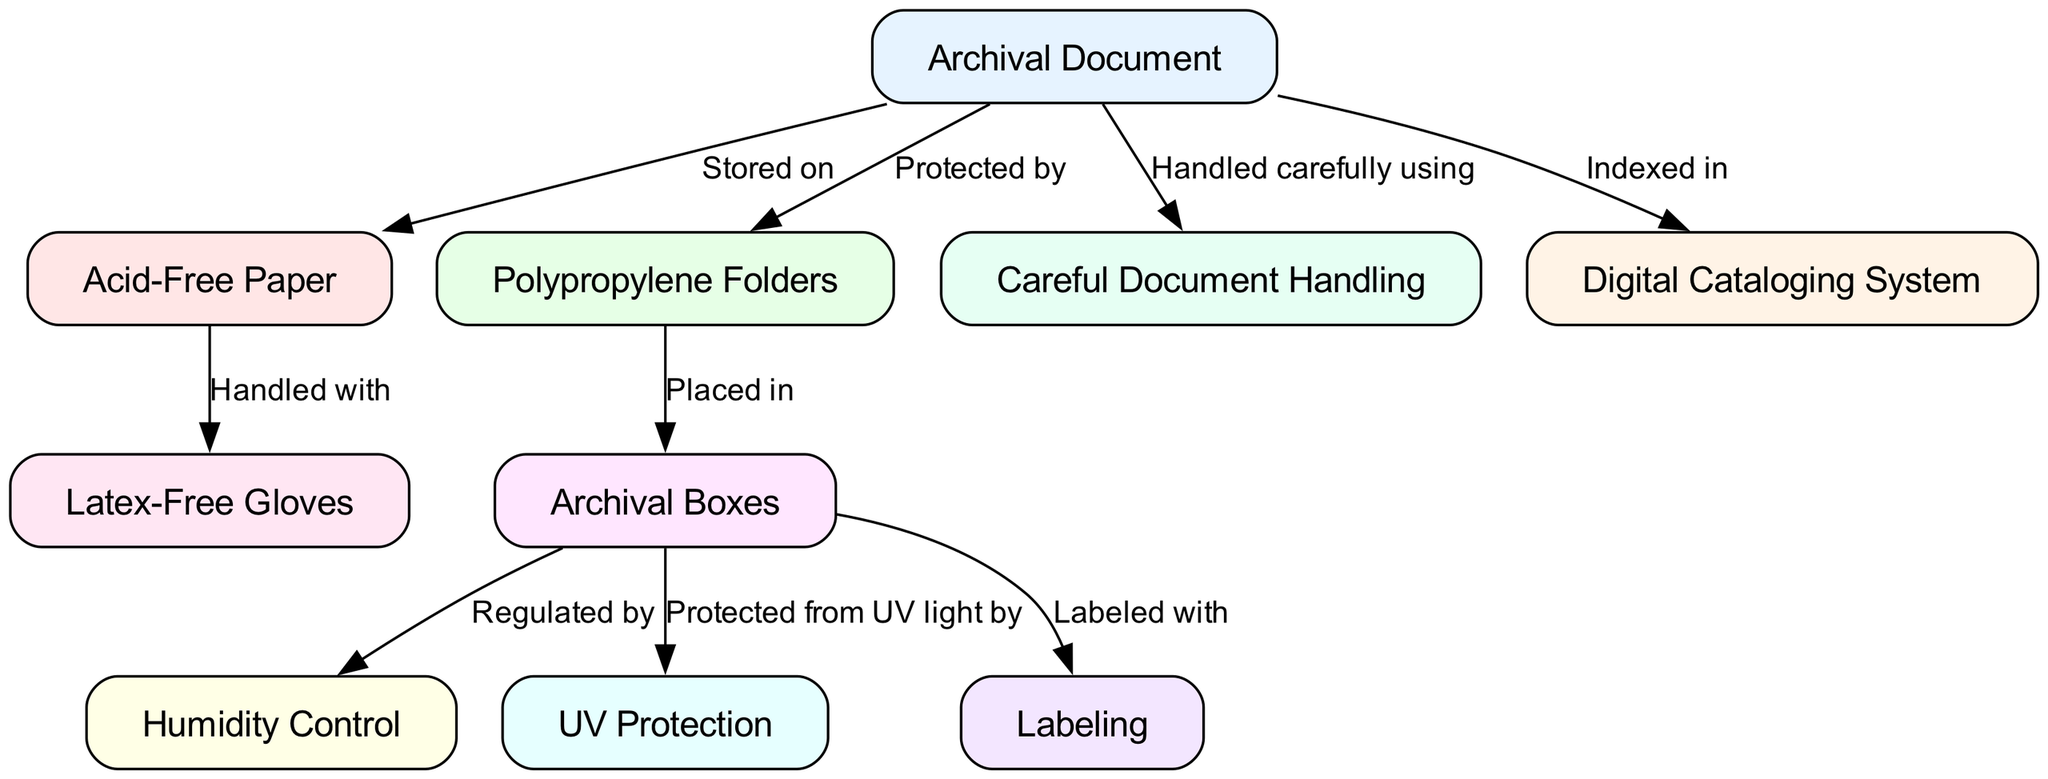What is the main component referenced as "Archival Document"? The diagram identifies "Archival Document" as the central item involved in preservation processes, represented as a main node.
Answer: Archival Document How many types of preservation materials are explicitly mentioned in the diagram? By analyzing the nodes listed, we see "Acid-Free Paper," "Polypropylene Folders," and "Archival Boxes," totaling three unique material types that are highlighted.
Answer: 3 What protective method is used to shield archival boxes from light? The edge labeled "Protected from UV light by" connects "Archival Boxes" to "UV Protection," signifying that UV Protection is the method indicated for shielding against light.
Answer: UV Protection What is the handling method for archival documents? The edge titled "Handled carefully using" connects "Archival Document" to "Careful Document Handling," demonstrating that the recommended method involves careful handling practices.
Answer: Careful Document Handling How is humidity controlled for archival boxes? The diagram shows an edge labeled "Regulated by" from "Archival Boxes" to "Humidity Control," indicating that humidity control measures are directly tied to the management of archival boxes.
Answer: Humidity Control In which system are the archival documents indexed? The arrow labeled "Indexed in" from "Archival Document" to "Digital Cataloging System" signifies that the cataloging of documents takes place within this digital framework.
Answer: Digital Cataloging System What type of gloves should be used when handling acid-free paper? The edge stating "Handled with" connects "Acid-Free Paper" to "Latex-Free Gloves," highlighting that latex-free gloves are the specific type to be used for handling to prevent contamination.
Answer: Latex-Free Gloves Which folder type is used to protect the archival documents? The phrase "Protected by" directed from "Archival Document" to "Polypropylene Folders" indicates that polypropylene folders serve as protective covers for the archival documents.
Answer: Polypropylene Folders What assisting tool is connected to archival boxes for labeling? The edge labeled "Labeled with" going from "Archival Boxes" to "Labeling" clarifies that labeling is the method used to indicate the contents or details regarding the archival boxes.
Answer: Labeling 